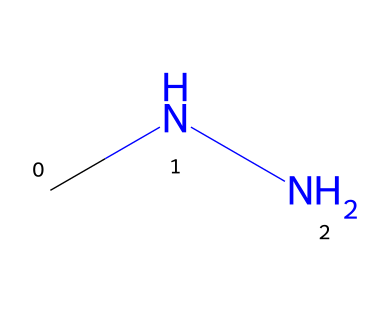What is the molecular formula of methylhydrazine? The structure represented by the SMILES "CNN" indicates the presence of two nitrogen atoms and four carbon and hydrogen atoms. Counting the atoms leads to the formula C2H8N2.
Answer: C2H8N2 How many nitrogen atoms are in methylhydrazine? From the SMILES representation "CNN", it shows two nitrogen (N) atoms in the structure.
Answer: 2 What type of functional group does methylhydrazine contain? The presence of the -NH2 group indicates that it contains an amine functional group, which is characteristic of hydrazines.
Answer: amine What relevance does the structure of methylhydrazine have concerning its toxicity? The nitrogens in the structure can be associated with its high reactivity and potential toxicity, typical of hydrazines.
Answer: reactivity What is the common use of methylhydrazine? Methylhydrazine is primarily utilized as a rocket fuel, given its energy properties highlighted by its hydrazine structure.
Answer: rocket fuel What is the total number of carbon and hydrogen atoms in methylhydrazine? The SMILES notation shows 2 carbons (C) and 8 hydrogens (H), which can be summed up to find the total.
Answer: 10 